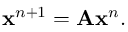Convert formula to latex. <formula><loc_0><loc_0><loc_500><loc_500>\begin{array} { r } { x ^ { n + 1 } = A x ^ { n } . } \end{array}</formula> 